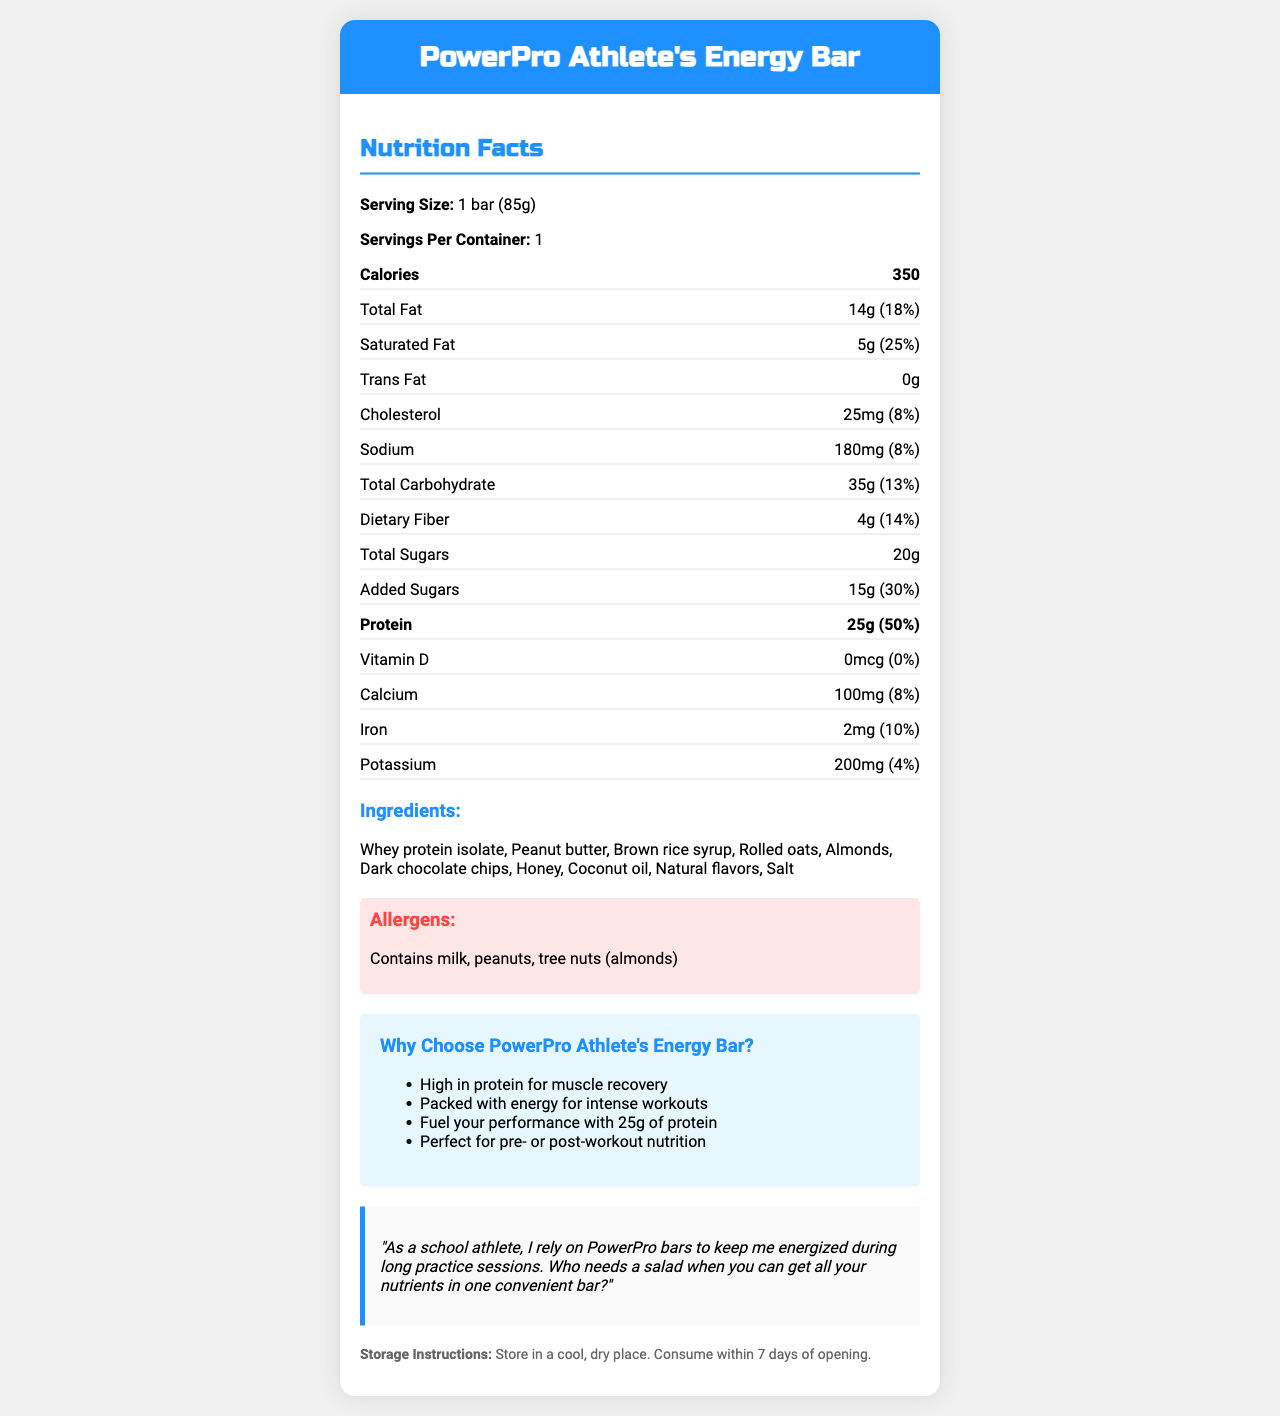what is the serving size of the PowerPro Athlete's Energy Bar? The document states the serving size as "1 bar (85g)" clearly at the beginning of the nutrition facts section.
Answer: 1 bar (85g) how many calories are in one serving of the PowerPro Athlete's Energy Bar? In the nutrition facts section, it states that one serving (one bar) contains 350 calories.
Answer: 350 how much protein is in one serving? Under the nutrition facts, it mentions "Protein: 25g (50% DV)".
Answer: 25g what percentage of daily value is the total fat? The document lists "Total Fat: 14g (18%)".
Answer: 18% how much added sugar does the energy bar contain? It is stated under the section for "Added Sugars: 15g (30% DV)".
Answer: 15g how many milligrams of sodium are in one serving? The sodium content is detailed as "Sodium: 180mg (8%)".
Answer: 180mg which of the following is not an ingredient in the PowerPro Athlete's Energy Bar? A. Whey protein isolate B. Peanut butter C. High fructose corn syrup D. Dark chocolate chips The ingredients section lists whey protein isolate, peanut butter, and dark chocolate chips, but does not list high fructose corn syrup.
Answer: C what is the daily value percentage of calcium in this energy bar? A. 4% B. 8% C. 10% D. 14% The document states "Calcium: 100mg (8%)".
Answer: B is there any trans fat in the PowerPro Athlete's Energy Bar? The nutrition facts explicitly list trans fat as "0g".
Answer: No summarize the key features of the PowerPro Athlete's Energy Bar. This summary captures the main aspects of the product, including its nutritional content, intended use, and key ingredients.
Answer: The PowerPro Athlete's Energy Bar is a high-protein energy bar designed for athletes, containing 25g of protein and 350 calories per serving. It includes various ingredients like whey protein isolate, peanut butter, and dark chocolate chips, and is intended for muscle recovery and intense workouts. The bar also contains 14g of fat, 35g of carbohydrates, and 20g of total sugars. It also highlights its nutritional benefits and includes testimonials and storage instructions. how many types of allergens are listed? The document specifies the allergens as "Contains milk, peanuts, and tree nuts (almonds)", totaling three types.
Answer: 3 what is the purpose of the coconut oil in the energy bar? The document lists coconut oil as an ingredient but does not specify its purpose.
Answer: Not enough information how long should the energy bar be consumed after opening? The storage instructions state to "Consume within 7 days of opening".
Answer: Within 7 days describe the marketing claims made about the PowerPro Athlete's Energy Bar. These claims are listed under the marketing claims section of the document.
Answer: The marketing claims include being high in protein for muscle recovery, packed with energy for intense workouts, and providing 25g of protein to fuel performance. It is recommended for pre- or post-workout nutrition. 